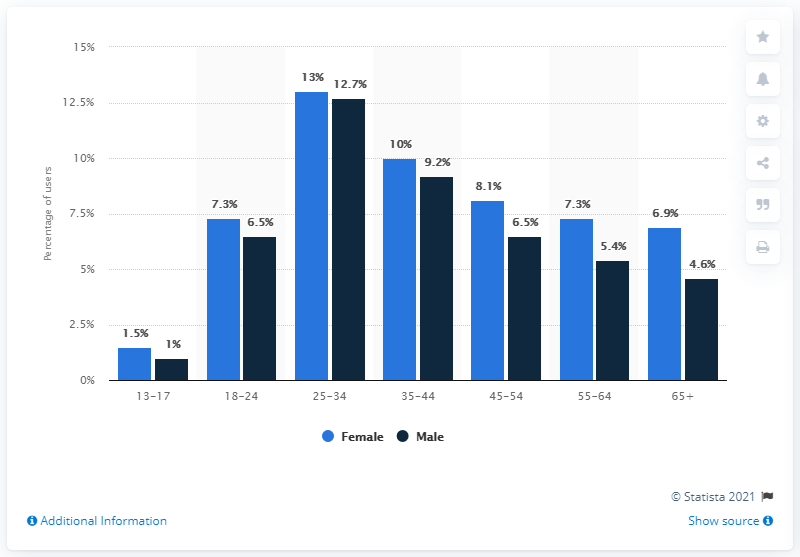Draw attention to some important aspects in this diagram. According to the data, female teenagers between the ages of 13 and 17 made up 1.5% of social media users. 